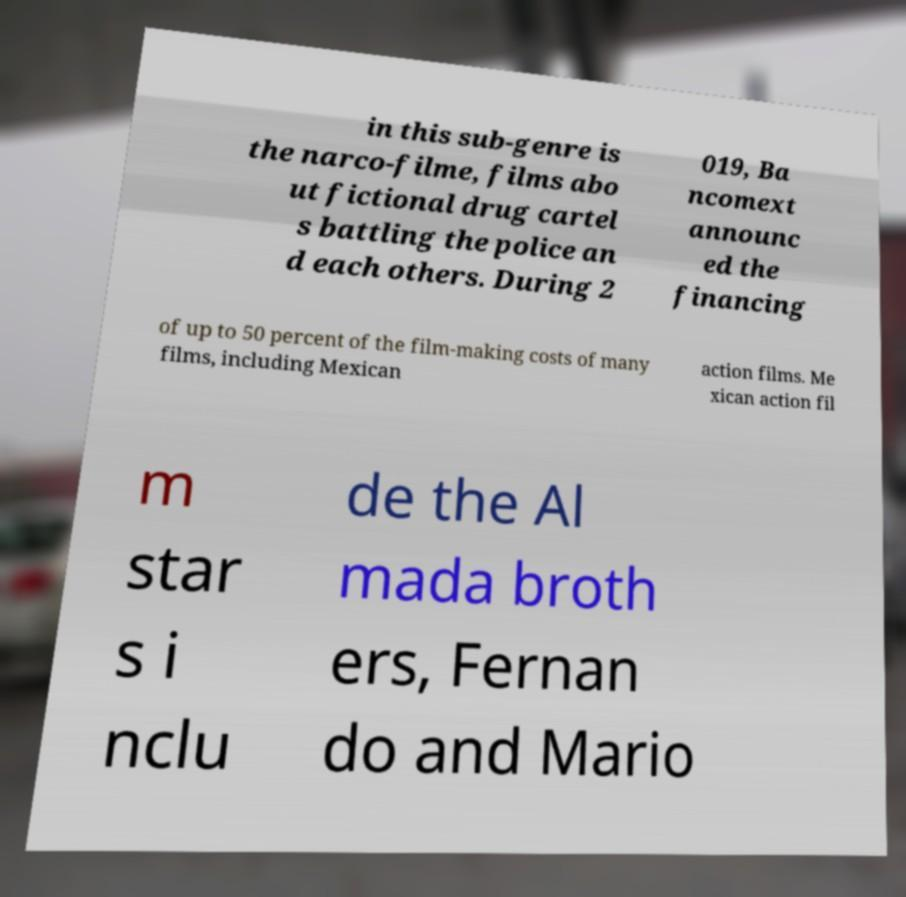There's text embedded in this image that I need extracted. Can you transcribe it verbatim? in this sub-genre is the narco-filme, films abo ut fictional drug cartel s battling the police an d each others. During 2 019, Ba ncomext announc ed the financing of up to 50 percent of the film-making costs of many films, including Mexican action films. Me xican action fil m star s i nclu de the Al mada broth ers, Fernan do and Mario 